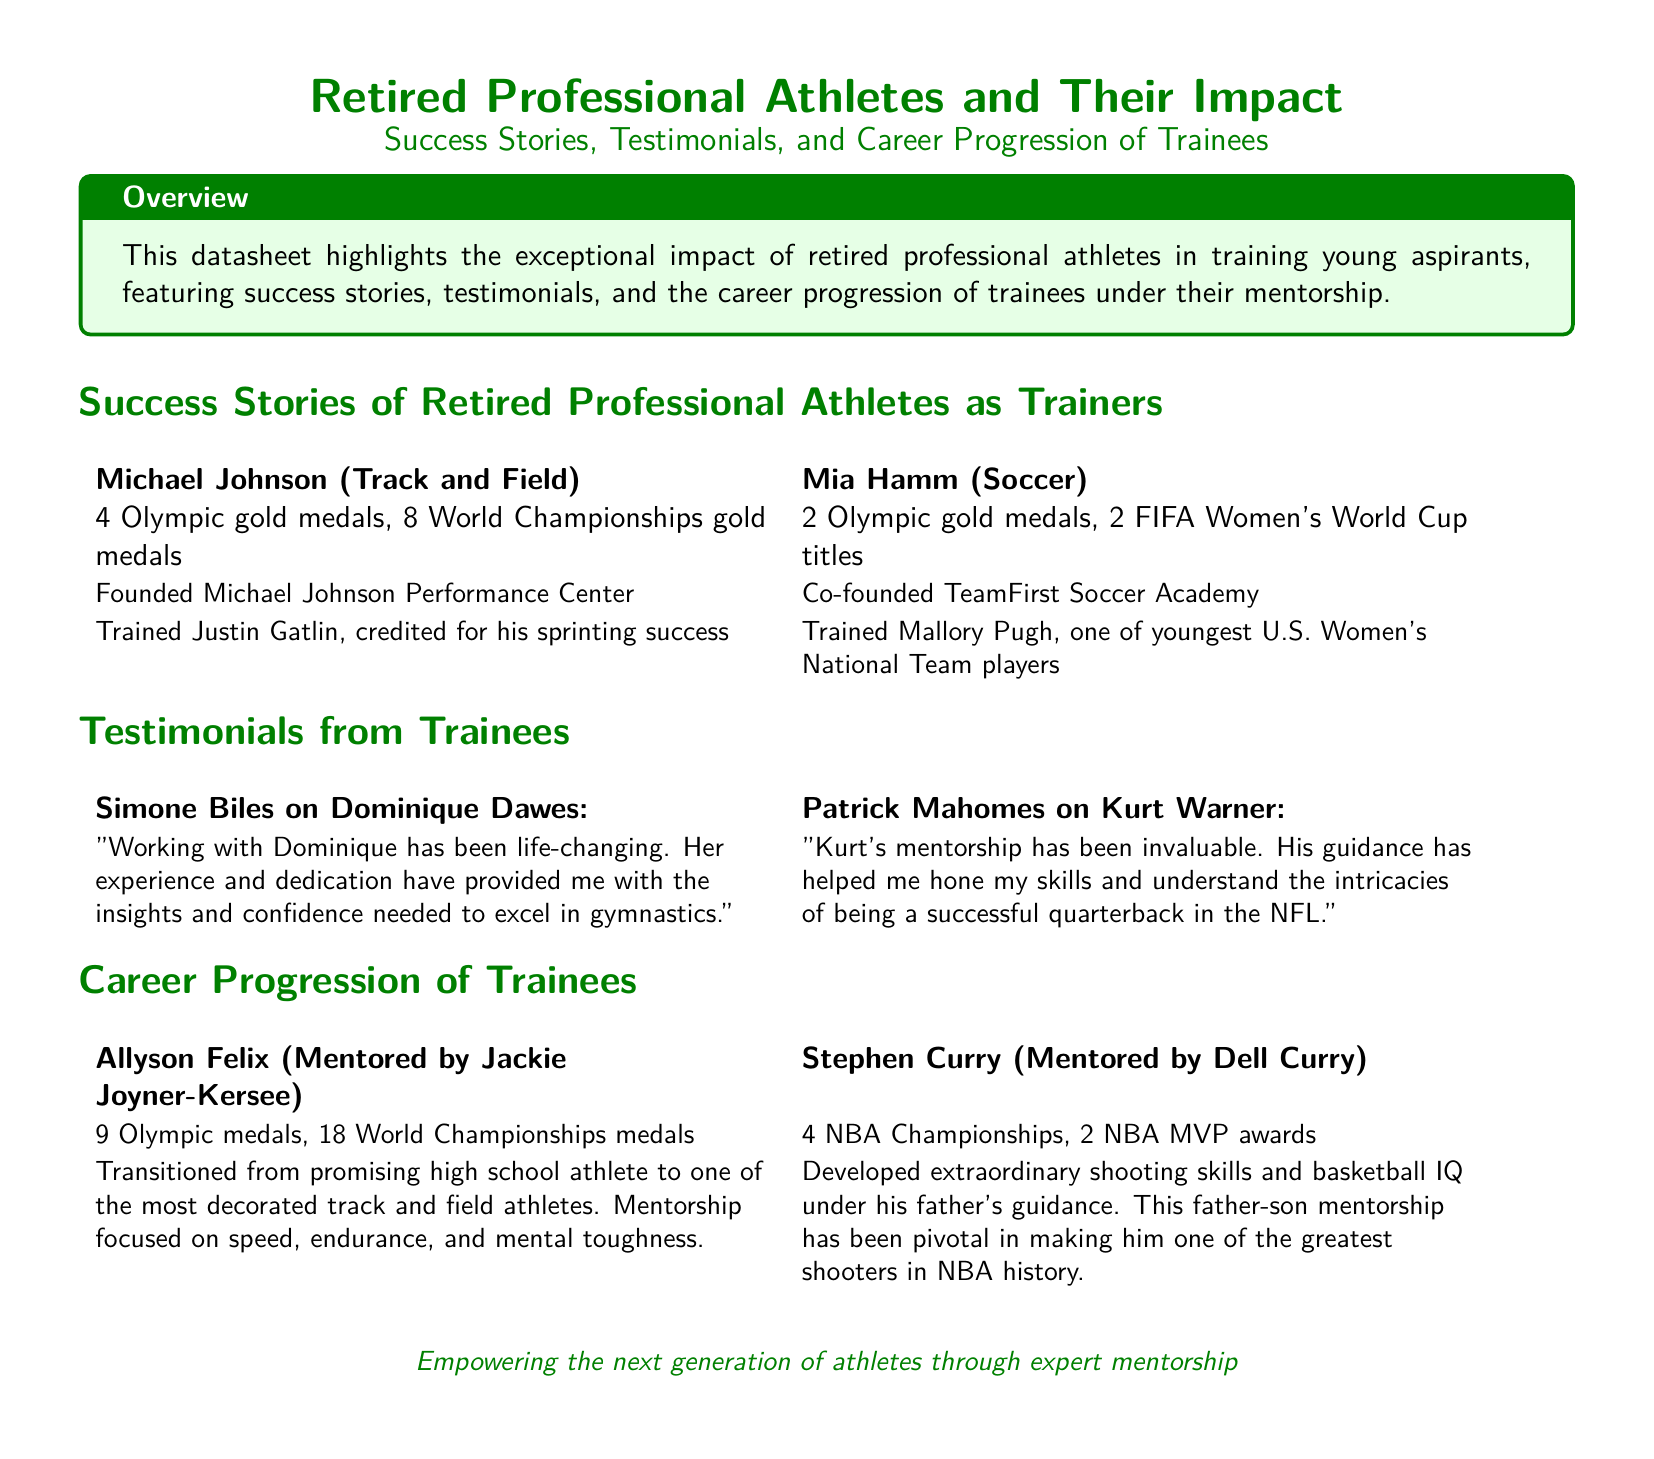What is the title of the datasheet? The title of the datasheet is found at the top, stating the focus of the content.
Answer: Retired Professional Athletes and Their Impact Who trained Justin Gatlin? This refers to the retired professional athlete who served as a trainer for Justin Gatlin.
Answer: Michael Johnson How many Olympic gold medals did Mia Hamm win? The document specifies the achievements of Mia Hamm in her sports career.
Answer: 2 What career progression did Allyson Felix achieve? This question pertains to the accomplishments and growth of Allyson Felix as noted in the document.
Answer: 9 Olympic medals, 18 World Championships medals What is the main theme of the datasheet? The overall subject of the datasheet summarizes the impact and importance of retired athletes mentoring trainees.
Answer: Success Stories, Testimonials, and Career Progression of Trainees Which athlete co-founded TeamFirst Soccer Academy? This question seeks to identify the retired athlete associated with the soccer academy.
Answer: Mia Hamm What did Kurt Warner provide to Patrick Mahomes? The document highlights the mentorship type offered by Warner to Mahomes.
Answer: Mentorship What is emphasized in the conclusion of the datasheet? This focuses on the final message regarding the intent of the retired athletes' involvement.
Answer: Empowering the next generation of athletes through expert mentorship 